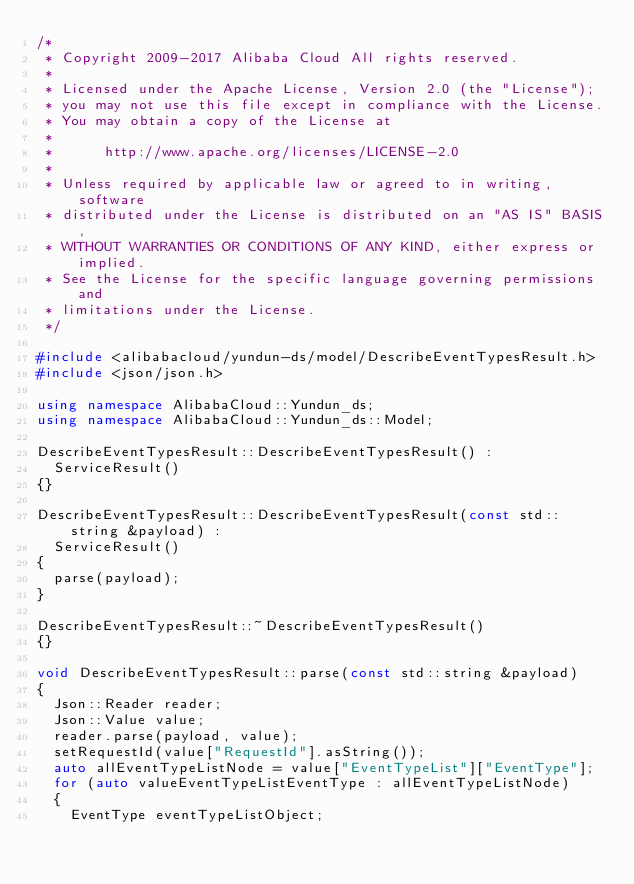<code> <loc_0><loc_0><loc_500><loc_500><_C++_>/*
 * Copyright 2009-2017 Alibaba Cloud All rights reserved.
 * 
 * Licensed under the Apache License, Version 2.0 (the "License");
 * you may not use this file except in compliance with the License.
 * You may obtain a copy of the License at
 * 
 *      http://www.apache.org/licenses/LICENSE-2.0
 * 
 * Unless required by applicable law or agreed to in writing, software
 * distributed under the License is distributed on an "AS IS" BASIS,
 * WITHOUT WARRANTIES OR CONDITIONS OF ANY KIND, either express or implied.
 * See the License for the specific language governing permissions and
 * limitations under the License.
 */

#include <alibabacloud/yundun-ds/model/DescribeEventTypesResult.h>
#include <json/json.h>

using namespace AlibabaCloud::Yundun_ds;
using namespace AlibabaCloud::Yundun_ds::Model;

DescribeEventTypesResult::DescribeEventTypesResult() :
	ServiceResult()
{}

DescribeEventTypesResult::DescribeEventTypesResult(const std::string &payload) :
	ServiceResult()
{
	parse(payload);
}

DescribeEventTypesResult::~DescribeEventTypesResult()
{}

void DescribeEventTypesResult::parse(const std::string &payload)
{
	Json::Reader reader;
	Json::Value value;
	reader.parse(payload, value);
	setRequestId(value["RequestId"].asString());
	auto allEventTypeListNode = value["EventTypeList"]["EventType"];
	for (auto valueEventTypeListEventType : allEventTypeListNode)
	{
		EventType eventTypeListObject;</code> 